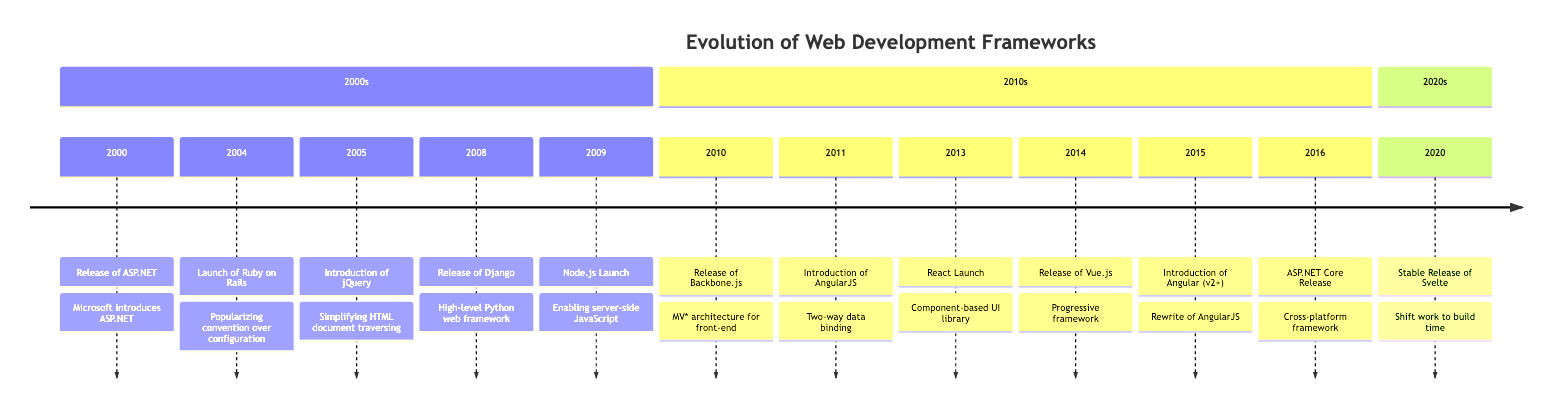What year was ASP.NET released? According to the timeline, ASP.NET was released in the year 2000.
Answer: 2000 How many frameworks were introduced in the 2010s? From the timeline, there are seven events listed in the 2010s section (Backbone.js, AngularJS, React, Vue.js, Angular v2+, ASP.NET Core).
Answer: 7 What is the main feature of Ruby on Rails highlighted in the diagram? The diagram indicates that Ruby on Rails popularized "convention over configuration" and "DRY principles."
Answer: Convention over configuration Which framework was released immediately before Node.js? The event preceding Node.js is the release of Django, which was introduced in 2008, while Node.js was launched in 2009.
Answer: Django What is the release status of Svelte in 2020? The timeline states that Svelte reached a stable release in 2020.
Answer: Stable release Which framework is recognized for server-side scripting using JavaScript? Node.js, introduced in 2009, is specifically noted for enabling server-side scripting with JavaScript.
Answer: Node.js How many frameworks were released before 2013? Counting the events from 2000 to 2012 presents six frameworks (ASP.NET, Ruby on Rails, jQuery, Django, Node.js, Backbone.js, and AngularJS).
Answer: 6 What architectural style does Backbone.js provide? Backbone.js is recognized in the timeline as providing a "MV* architecture for front-end development."
Answer: MV* architecture What year did Angular (v2+) get released? The timeline specifies that Angular (v2+) was released in 2015.
Answer: 2015 